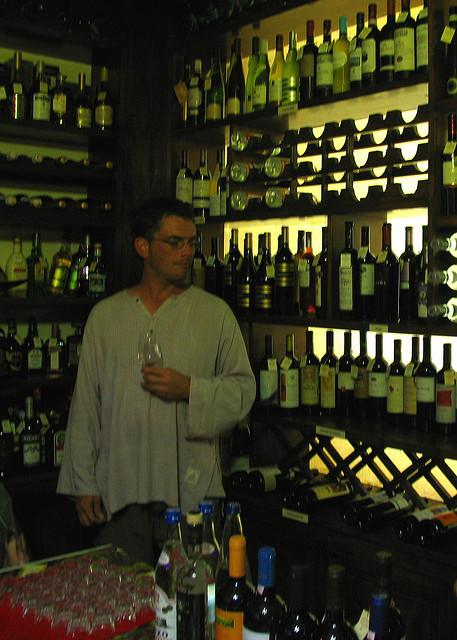Where is the man?

Choices:
A) garage
B) wine store
C) garden
D) stadium wine store 